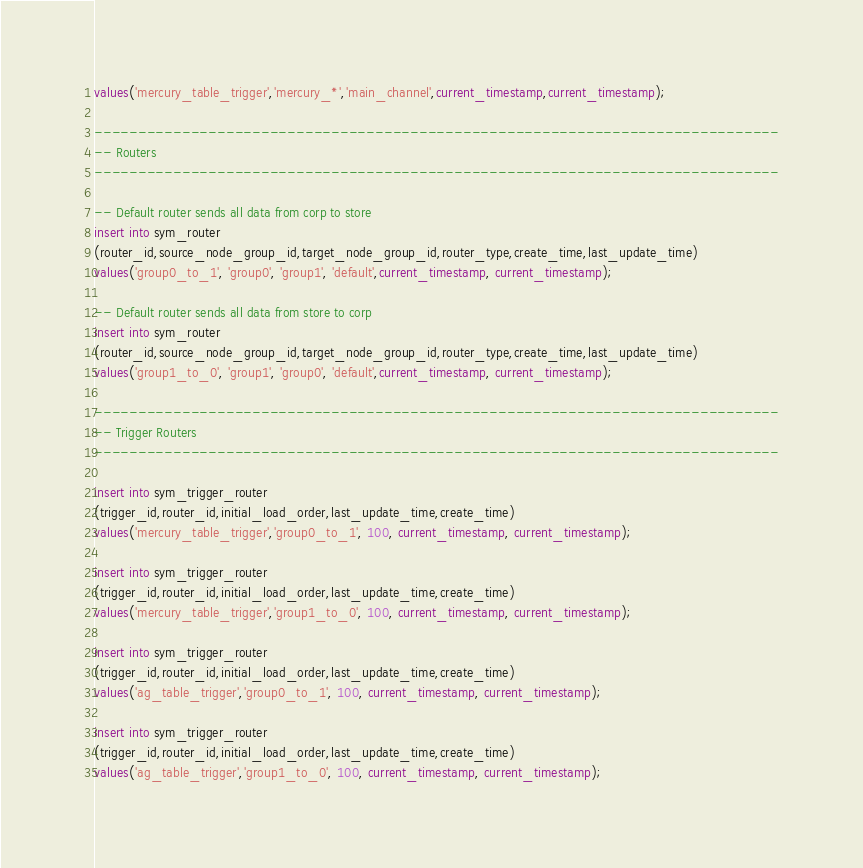<code> <loc_0><loc_0><loc_500><loc_500><_SQL_>values('mercury_table_trigger','mercury_*','main_channel',current_timestamp,current_timestamp);

------------------------------------------------------------------------------
-- Routers
------------------------------------------------------------------------------

-- Default router sends all data from corp to store
insert into sym_router
(router_id,source_node_group_id,target_node_group_id,router_type,create_time,last_update_time)
values('group0_to_1', 'group0', 'group1', 'default',current_timestamp, current_timestamp);

-- Default router sends all data from store to corp
insert into sym_router
(router_id,source_node_group_id,target_node_group_id,router_type,create_time,last_update_time)
values('group1_to_0', 'group1', 'group0', 'default',current_timestamp, current_timestamp);

------------------------------------------------------------------------------
-- Trigger Routers
------------------------------------------------------------------------------

insert into sym_trigger_router
(trigger_id,router_id,initial_load_order,last_update_time,create_time)
values('mercury_table_trigger','group0_to_1', 100, current_timestamp, current_timestamp);

insert into sym_trigger_router
(trigger_id,router_id,initial_load_order,last_update_time,create_time)
values('mercury_table_trigger','group1_to_0', 100, current_timestamp, current_timestamp);

insert into sym_trigger_router
(trigger_id,router_id,initial_load_order,last_update_time,create_time)
values('ag_table_trigger','group0_to_1', 100, current_timestamp, current_timestamp);

insert into sym_trigger_router
(trigger_id,router_id,initial_load_order,last_update_time,create_time)
values('ag_table_trigger','group1_to_0', 100, current_timestamp, current_timestamp);
</code> 